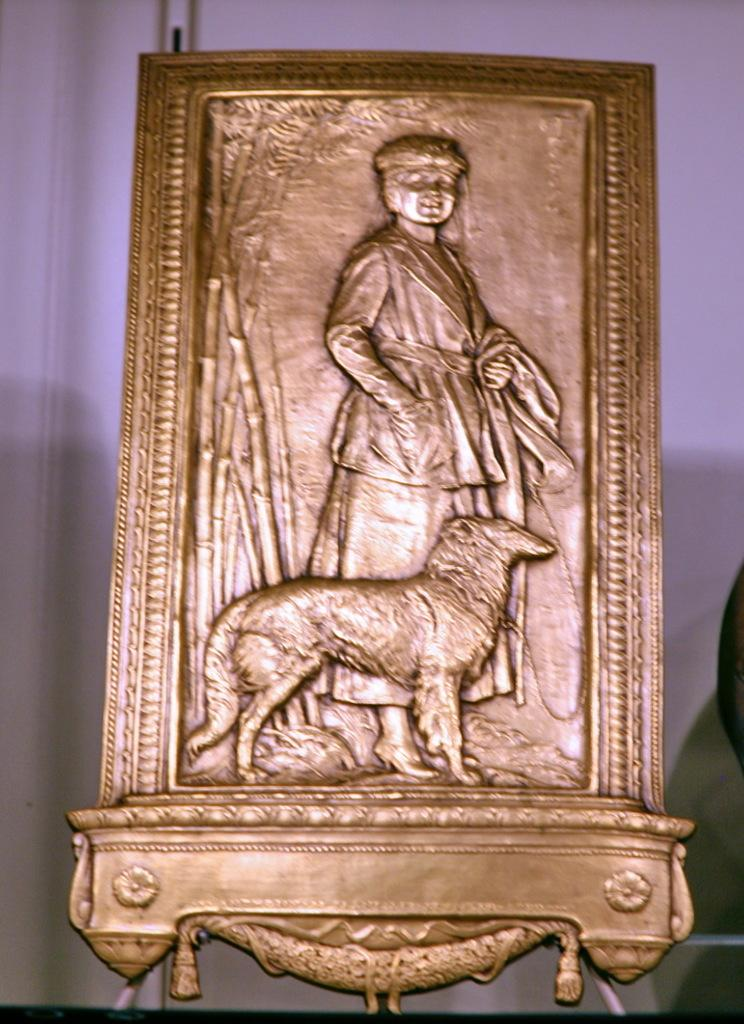What is located in the foreground of the image? There is a golden frame in the foreground of the image. What can be seen in the background of the image? There appears to be a wall in the background of the image. What type of toys can be seen on the roof in the image? There is no roof or toys present in the image; it only features a golden frame in the foreground and a wall in the background. 